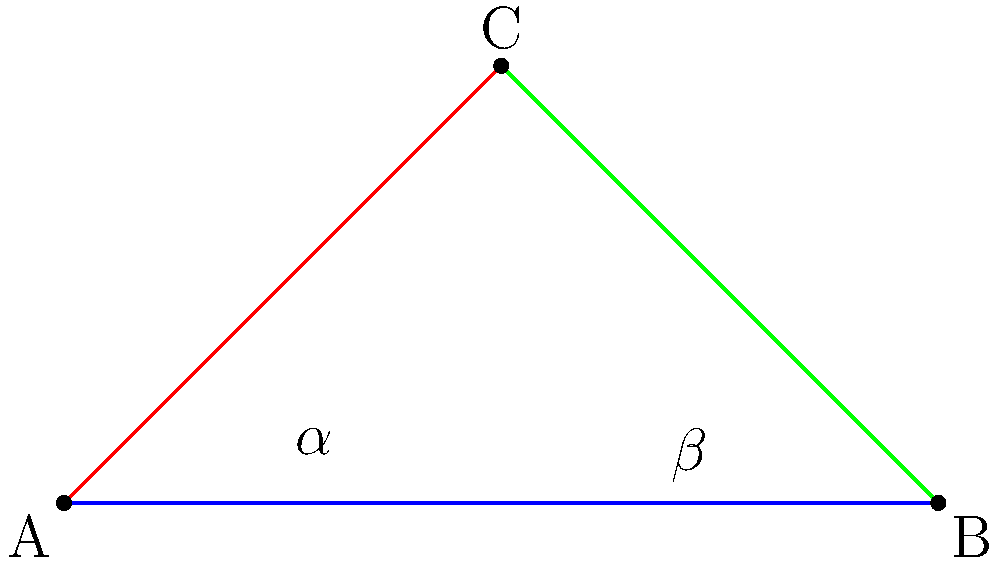In Lobachevskian geometry, consider two parallel lines that diverge from a common point A. If the angle of parallelism for one line is $\alpha$ and for the other is $\beta$, what is the relationship between these angles? How does this differ from Euclidean geometry, and what implications might this have for the concept of democratic representation in a religiously diverse society? 1. In Lobachevskian (hyperbolic) geometry, parallel lines behave differently than in Euclidean geometry:
   - Parallel lines diverge from each other as they extend from a common point.
   - The sum of angles in a triangle is less than 180°.

2. The angle of parallelism is a unique concept in hyperbolic geometry:
   - It's the angle between a line and the limiting parallel line through a point not on that line.
   - The angle of parallelism depends on the distance from the point to the line.

3. In Lobachevskian geometry, for two different parallel lines through point A:
   $\alpha + \beta < 180°$

4. This differs from Euclidean geometry where:
   $\alpha + \beta = 180°$

5. The relationship between $\alpha$ and $\beta$ in Lobachevskian geometry:
   $\tan(\frac{\alpha}{2}) \cdot \tan(\frac{\beta}{2}) = 1$

6. Implications for democratic representation:
   - Just as parallel lines in Lobachevskian geometry diverge, different religious perspectives in politics may lead to diverging policy outcomes.
   - The non-intuitive nature of this geometry reflects how religious influence can complicate democratic processes in unexpected ways.
   - The sum of angles being less than 180° could represent how religious diversity might reduce the total "political space" available for secular democratic decision-making.
Answer: $\tan(\frac{\alpha}{2}) \cdot \tan(\frac{\beta}{2}) = 1$, $\alpha + \beta < 180°$ 